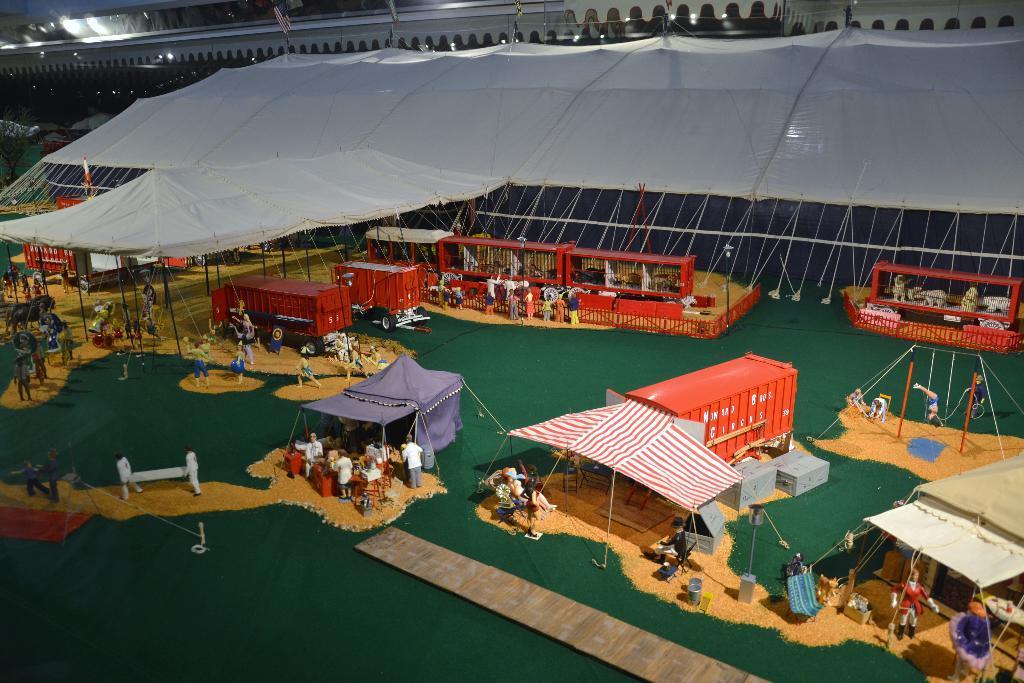How would you summarize this image in a sentence or two? In this image we can see tents. There are vehicles. At the bottom there are people standing and we can see some toys. 